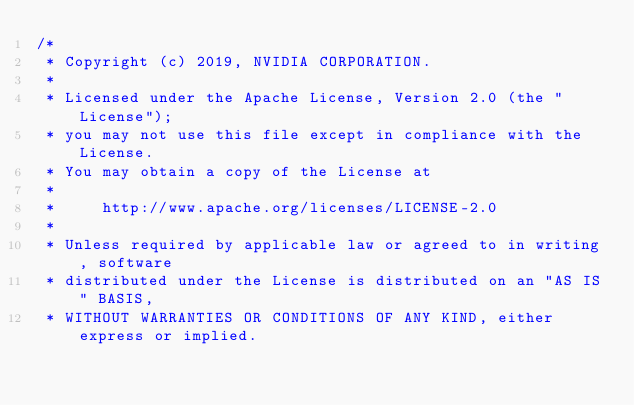Convert code to text. <code><loc_0><loc_0><loc_500><loc_500><_Cuda_>/*
 * Copyright (c) 2019, NVIDIA CORPORATION.
 *
 * Licensed under the Apache License, Version 2.0 (the "License");
 * you may not use this file except in compliance with the License.
 * You may obtain a copy of the License at
 *
 *     http://www.apache.org/licenses/LICENSE-2.0
 *
 * Unless required by applicable law or agreed to in writing, software
 * distributed under the License is distributed on an "AS IS" BASIS,
 * WITHOUT WARRANTIES OR CONDITIONS OF ANY KIND, either express or implied.</code> 